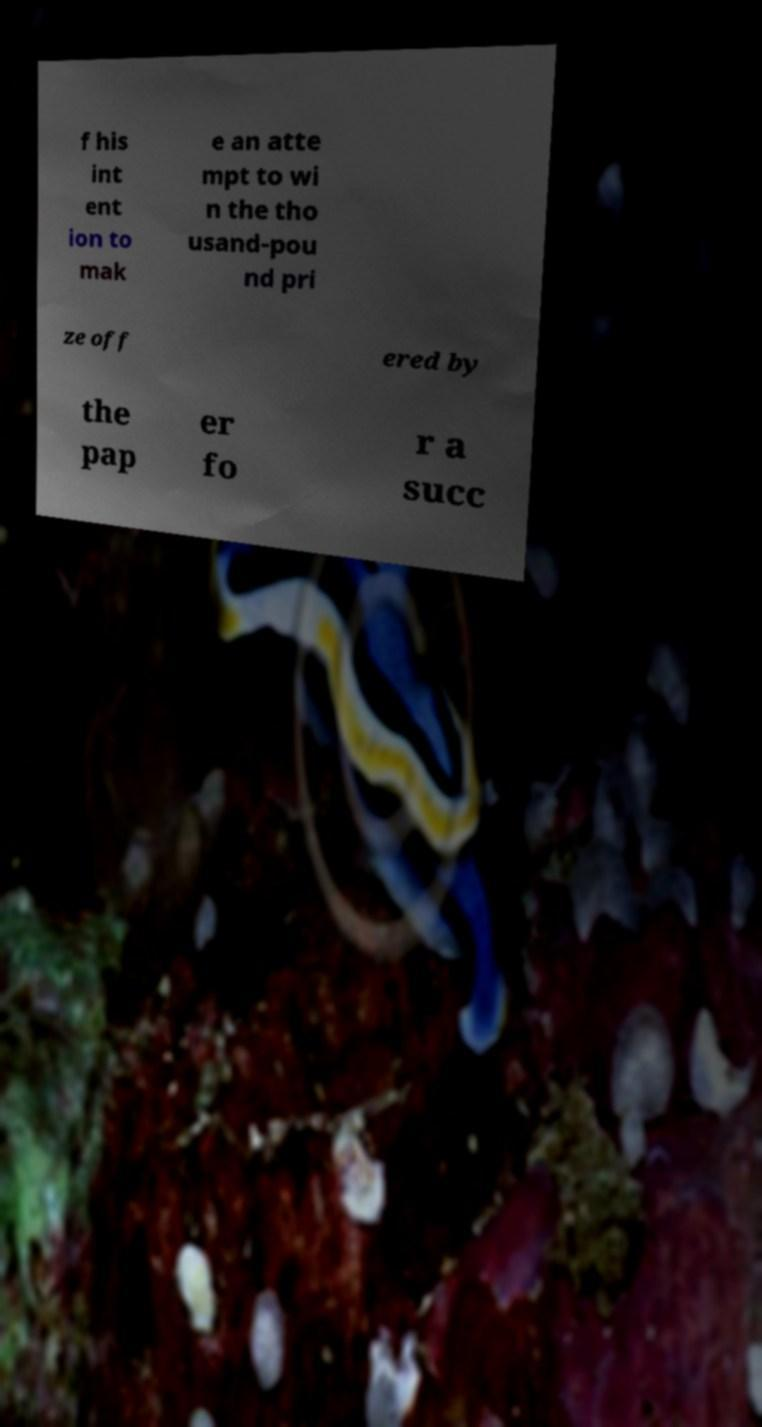Could you assist in decoding the text presented in this image and type it out clearly? f his int ent ion to mak e an atte mpt to wi n the tho usand-pou nd pri ze off ered by the pap er fo r a succ 